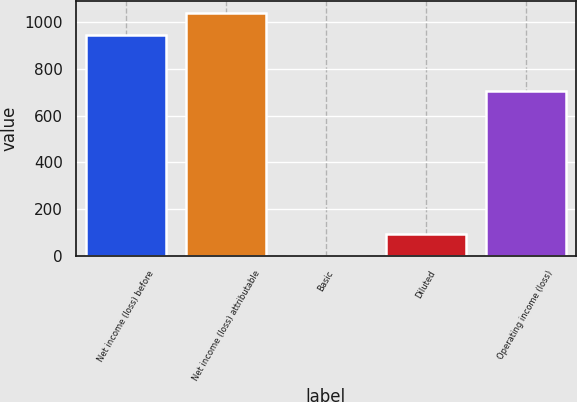Convert chart to OTSL. <chart><loc_0><loc_0><loc_500><loc_500><bar_chart><fcel>Net income (loss) before<fcel>Net income (loss) attributable<fcel>Basic<fcel>Diluted<fcel>Operating income (loss)<nl><fcel>945<fcel>1039.5<fcel>0.01<fcel>94.51<fcel>708<nl></chart> 